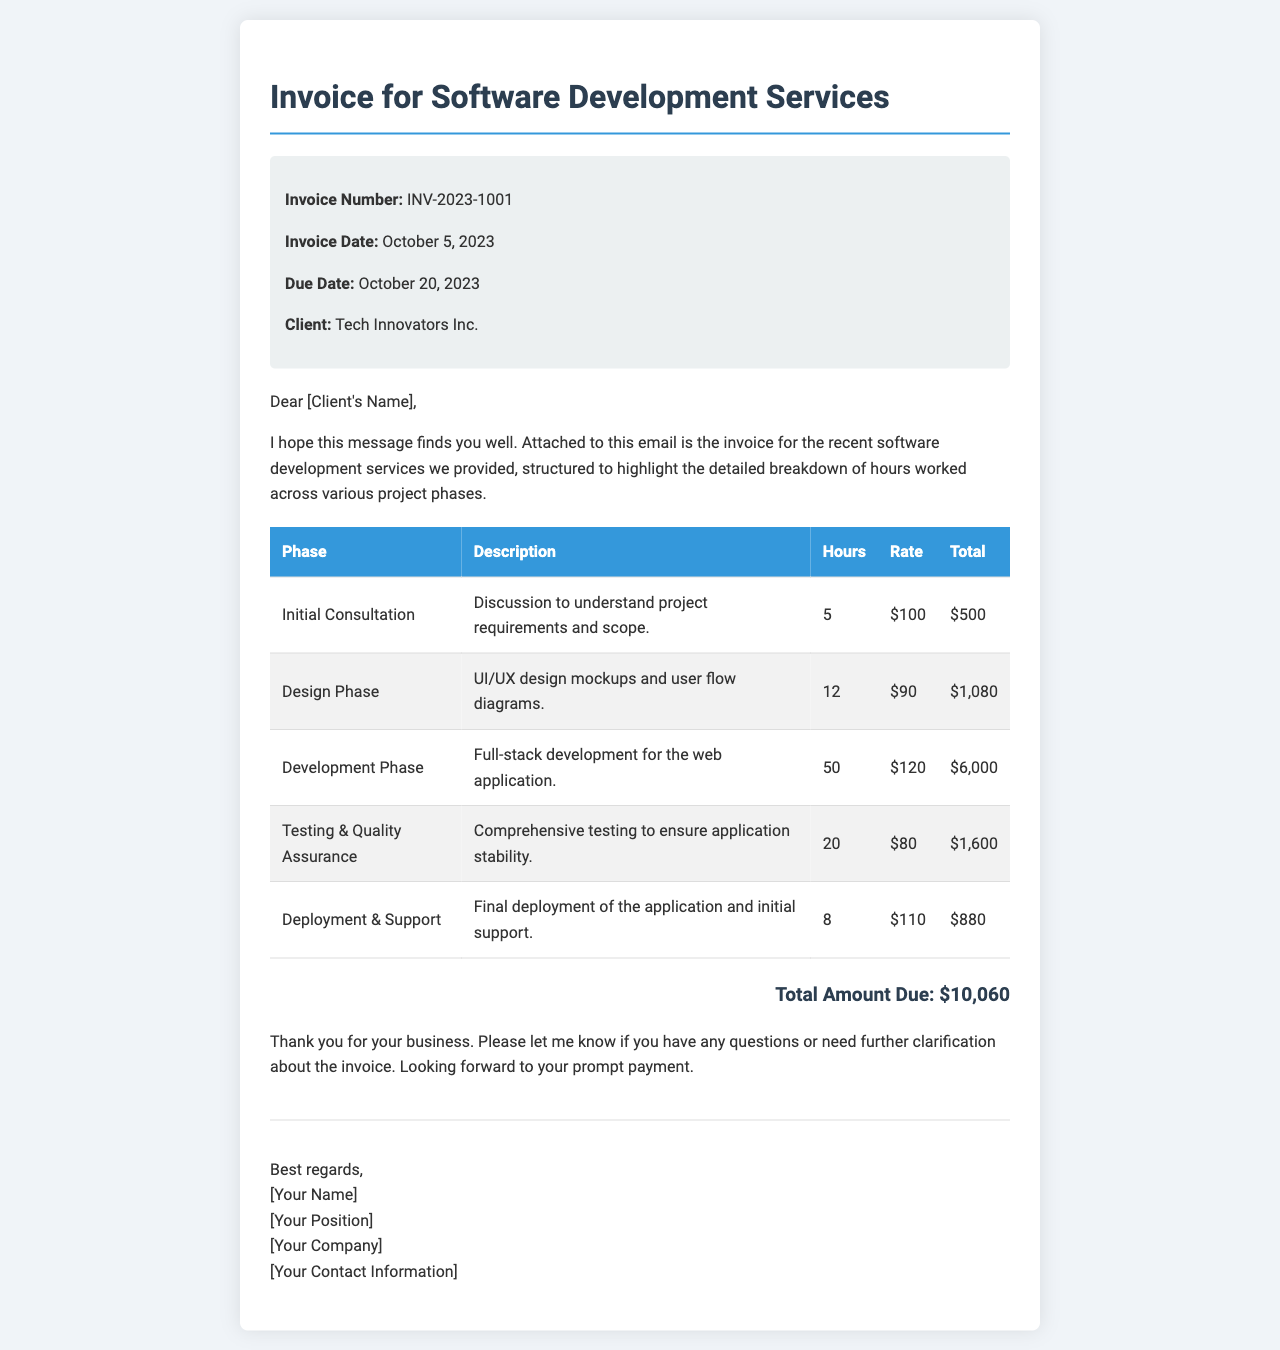What is the invoice number? The invoice number is a unique identifier for the invoice, which is stated in the document as INV-2023-1001.
Answer: INV-2023-1001 What is the due date for the invoice? The due date is the last day by which payment must be made, specified in the document as October 20, 2023.
Answer: October 20, 2023 How many hours were spent on the Development Phase? The document lists hours worked in each phase, with the Development Phase showing 50 hours spent.
Answer: 50 What is the total amount due? The total amount due is the final sum calculated from all phases, provided as $10,060 in the document.
Answer: $10,060 What is the rate for hours in the Testing & Quality Assurance phase? The rate for Testing & Quality Assurance is stated in the document as $80 per hour.
Answer: $80 Which company is the client? The client's name is indicated in the invoice details, which specifies it as Tech Innovators Inc.
Answer: Tech Innovators Inc How many phases are listed in the invoice? The document lists five distinct project phases in the table of services rendered.
Answer: Five What is the total hours worked across all phases? The total hours can be derived by adding the hours from all the phases, which equals 95 hours.
Answer: 95 What service was provided during the Initial Consultation phase? The Initial Consultation phase involved discussions to understand project requirements and scope, as described in the document.
Answer: Discussion to understand project requirements and scope 